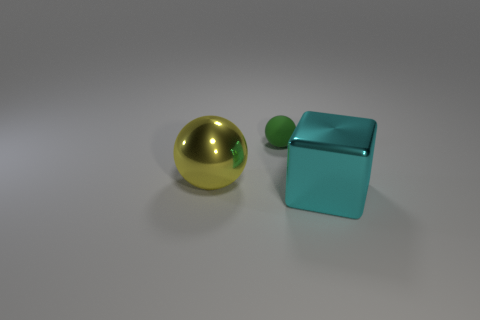Are there more shiny objects to the right of the big metal block than metallic blocks?
Keep it short and to the point. No. Do the shiny ball and the matte ball have the same color?
Make the answer very short. No. How many other small red rubber things are the same shape as the small thing?
Keep it short and to the point. 0. There is a cyan object that is the same material as the yellow ball; what size is it?
Your response must be concise. Large. The thing that is behind the cyan block and in front of the rubber sphere is what color?
Your answer should be compact. Yellow. How many other spheres are the same size as the rubber ball?
Make the answer very short. 0. What is the size of the thing that is right of the large shiny ball and in front of the small matte thing?
Your answer should be compact. Large. There is a shiny thing on the left side of the big metallic cube that is on the right side of the yellow shiny thing; how many objects are behind it?
Your response must be concise. 1. Are there any shiny objects of the same color as the tiny sphere?
Ensure brevity in your answer.  No. There is another object that is the same size as the yellow shiny thing; what is its color?
Make the answer very short. Cyan. 